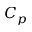<formula> <loc_0><loc_0><loc_500><loc_500>C _ { p }</formula> 